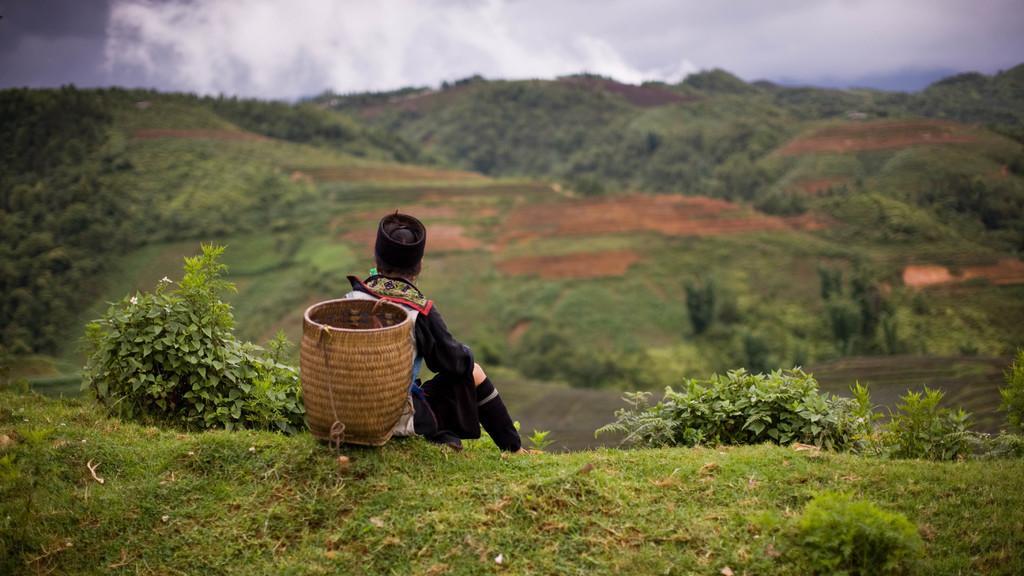Describe this image in one or two sentences. Woman sitting on a grass carrying a basket which is in brown color. Women wore hat and black dress. Beside this woman there are plants. Far away there are trees. The sky is very cloudy. 